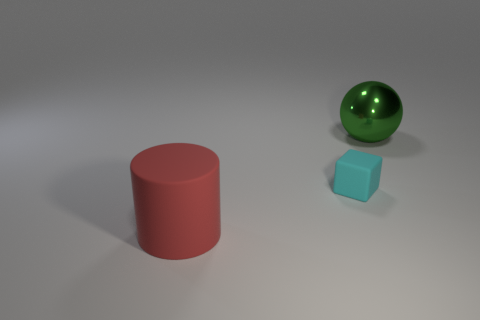There is a thing that is both in front of the green object and behind the red rubber cylinder; what is its shape?
Provide a short and direct response. Cube. How many things have the same material as the cyan cube?
Provide a succinct answer. 1. There is a rubber thing that is behind the big red thing; what number of green metal spheres are left of it?
Provide a succinct answer. 0. There is a big thing behind the large object in front of the large thing behind the big cylinder; what shape is it?
Your response must be concise. Sphere. How many objects are either purple shiny cylinders or big red cylinders?
Make the answer very short. 1. The thing that is the same size as the ball is what color?
Offer a terse response. Red. Does the large green metal object have the same shape as the matte thing that is right of the rubber cylinder?
Offer a terse response. No. What number of things are large things on the right side of the cylinder or large things that are to the right of the tiny cyan cube?
Keep it short and to the point. 1. What is the shape of the matte thing behind the big matte object?
Make the answer very short. Cube. There is a big thing that is in front of the shiny ball; is its shape the same as the cyan rubber object?
Provide a succinct answer. No. 